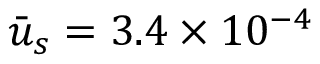Convert formula to latex. <formula><loc_0><loc_0><loc_500><loc_500>\bar { u } _ { s } = 3 . 4 \times { 1 0 ^ { - 4 } }</formula> 